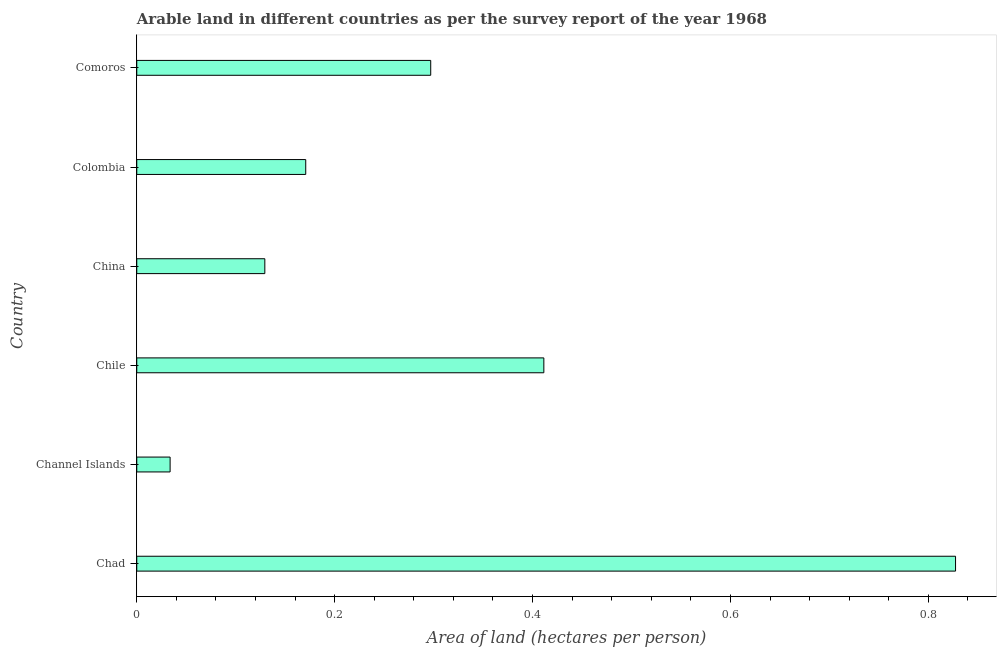Does the graph contain any zero values?
Offer a very short reply. No. Does the graph contain grids?
Your response must be concise. No. What is the title of the graph?
Give a very brief answer. Arable land in different countries as per the survey report of the year 1968. What is the label or title of the X-axis?
Provide a short and direct response. Area of land (hectares per person). What is the label or title of the Y-axis?
Ensure brevity in your answer.  Country. What is the area of arable land in China?
Your response must be concise. 0.13. Across all countries, what is the maximum area of arable land?
Your response must be concise. 0.83. Across all countries, what is the minimum area of arable land?
Offer a very short reply. 0.03. In which country was the area of arable land maximum?
Your answer should be very brief. Chad. In which country was the area of arable land minimum?
Offer a terse response. Channel Islands. What is the sum of the area of arable land?
Your response must be concise. 1.87. What is the difference between the area of arable land in China and Comoros?
Offer a terse response. -0.17. What is the average area of arable land per country?
Provide a short and direct response. 0.31. What is the median area of arable land?
Provide a succinct answer. 0.23. What is the ratio of the area of arable land in Chile to that in China?
Offer a very short reply. 3.18. Is the area of arable land in Chad less than that in Chile?
Provide a short and direct response. No. Is the difference between the area of arable land in Chile and Colombia greater than the difference between any two countries?
Your answer should be very brief. No. What is the difference between the highest and the second highest area of arable land?
Give a very brief answer. 0.42. What is the difference between the highest and the lowest area of arable land?
Your answer should be compact. 0.79. In how many countries, is the area of arable land greater than the average area of arable land taken over all countries?
Your answer should be very brief. 2. How many bars are there?
Make the answer very short. 6. Are all the bars in the graph horizontal?
Provide a succinct answer. Yes. How many countries are there in the graph?
Give a very brief answer. 6. What is the difference between two consecutive major ticks on the X-axis?
Offer a very short reply. 0.2. Are the values on the major ticks of X-axis written in scientific E-notation?
Your response must be concise. No. What is the Area of land (hectares per person) in Chad?
Your answer should be compact. 0.83. What is the Area of land (hectares per person) in Channel Islands?
Ensure brevity in your answer.  0.03. What is the Area of land (hectares per person) of Chile?
Your answer should be very brief. 0.41. What is the Area of land (hectares per person) of China?
Provide a succinct answer. 0.13. What is the Area of land (hectares per person) of Colombia?
Keep it short and to the point. 0.17. What is the Area of land (hectares per person) in Comoros?
Provide a succinct answer. 0.3. What is the difference between the Area of land (hectares per person) in Chad and Channel Islands?
Your answer should be very brief. 0.79. What is the difference between the Area of land (hectares per person) in Chad and Chile?
Your answer should be very brief. 0.42. What is the difference between the Area of land (hectares per person) in Chad and China?
Your answer should be very brief. 0.7. What is the difference between the Area of land (hectares per person) in Chad and Colombia?
Give a very brief answer. 0.66. What is the difference between the Area of land (hectares per person) in Chad and Comoros?
Your response must be concise. 0.53. What is the difference between the Area of land (hectares per person) in Channel Islands and Chile?
Offer a very short reply. -0.38. What is the difference between the Area of land (hectares per person) in Channel Islands and China?
Your response must be concise. -0.1. What is the difference between the Area of land (hectares per person) in Channel Islands and Colombia?
Provide a succinct answer. -0.14. What is the difference between the Area of land (hectares per person) in Channel Islands and Comoros?
Give a very brief answer. -0.26. What is the difference between the Area of land (hectares per person) in Chile and China?
Your answer should be very brief. 0.28. What is the difference between the Area of land (hectares per person) in Chile and Colombia?
Offer a very short reply. 0.24. What is the difference between the Area of land (hectares per person) in Chile and Comoros?
Make the answer very short. 0.11. What is the difference between the Area of land (hectares per person) in China and Colombia?
Ensure brevity in your answer.  -0.04. What is the difference between the Area of land (hectares per person) in China and Comoros?
Your response must be concise. -0.17. What is the difference between the Area of land (hectares per person) in Colombia and Comoros?
Make the answer very short. -0.13. What is the ratio of the Area of land (hectares per person) in Chad to that in Channel Islands?
Offer a terse response. 24.56. What is the ratio of the Area of land (hectares per person) in Chad to that in Chile?
Your answer should be very brief. 2.01. What is the ratio of the Area of land (hectares per person) in Chad to that in China?
Your response must be concise. 6.39. What is the ratio of the Area of land (hectares per person) in Chad to that in Colombia?
Keep it short and to the point. 4.85. What is the ratio of the Area of land (hectares per person) in Chad to that in Comoros?
Provide a succinct answer. 2.79. What is the ratio of the Area of land (hectares per person) in Channel Islands to that in Chile?
Your answer should be compact. 0.08. What is the ratio of the Area of land (hectares per person) in Channel Islands to that in China?
Keep it short and to the point. 0.26. What is the ratio of the Area of land (hectares per person) in Channel Islands to that in Colombia?
Offer a very short reply. 0.2. What is the ratio of the Area of land (hectares per person) in Channel Islands to that in Comoros?
Provide a succinct answer. 0.11. What is the ratio of the Area of land (hectares per person) in Chile to that in China?
Offer a very short reply. 3.18. What is the ratio of the Area of land (hectares per person) in Chile to that in Colombia?
Keep it short and to the point. 2.41. What is the ratio of the Area of land (hectares per person) in Chile to that in Comoros?
Provide a short and direct response. 1.39. What is the ratio of the Area of land (hectares per person) in China to that in Colombia?
Offer a terse response. 0.76. What is the ratio of the Area of land (hectares per person) in China to that in Comoros?
Keep it short and to the point. 0.44. What is the ratio of the Area of land (hectares per person) in Colombia to that in Comoros?
Your answer should be compact. 0.57. 